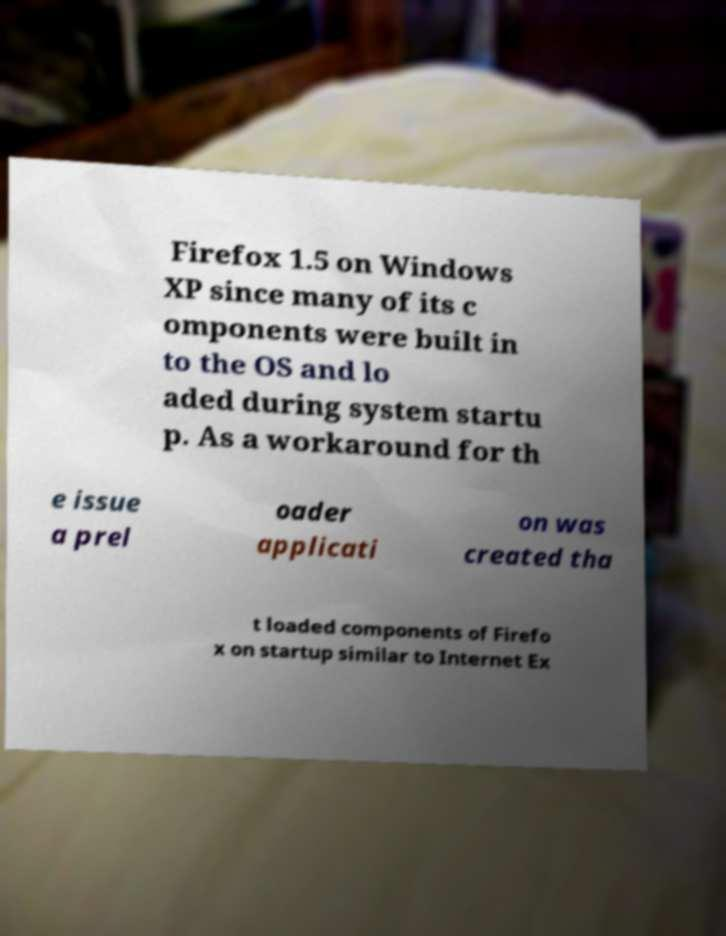I need the written content from this picture converted into text. Can you do that? Firefox 1.5 on Windows XP since many of its c omponents were built in to the OS and lo aded during system startu p. As a workaround for th e issue a prel oader applicati on was created tha t loaded components of Firefo x on startup similar to Internet Ex 